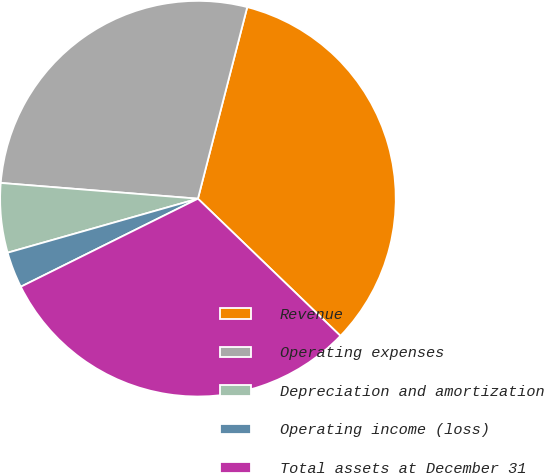Convert chart to OTSL. <chart><loc_0><loc_0><loc_500><loc_500><pie_chart><fcel>Revenue<fcel>Operating expenses<fcel>Depreciation and amortization<fcel>Operating income (loss)<fcel>Total assets at December 31<nl><fcel>33.19%<fcel>27.74%<fcel>5.67%<fcel>2.94%<fcel>30.46%<nl></chart> 